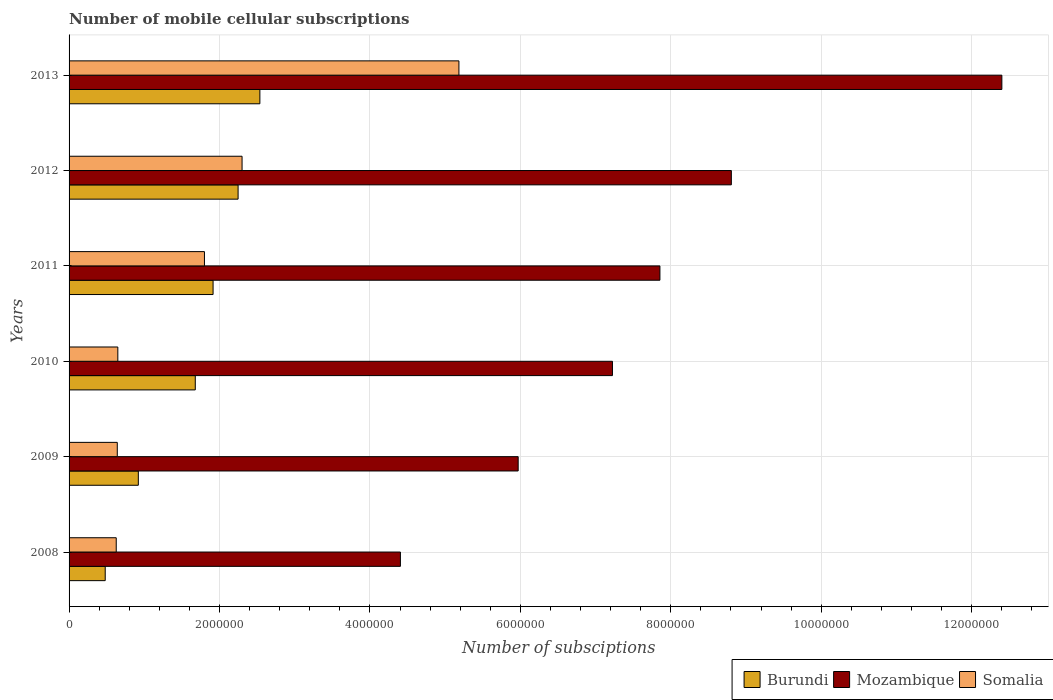How many different coloured bars are there?
Offer a very short reply. 3. Are the number of bars per tick equal to the number of legend labels?
Your answer should be compact. Yes. How many bars are there on the 1st tick from the bottom?
Offer a very short reply. 3. In how many cases, is the number of bars for a given year not equal to the number of legend labels?
Give a very brief answer. 0. What is the number of mobile cellular subscriptions in Mozambique in 2012?
Your response must be concise. 8.80e+06. Across all years, what is the maximum number of mobile cellular subscriptions in Mozambique?
Keep it short and to the point. 1.24e+07. Across all years, what is the minimum number of mobile cellular subscriptions in Burundi?
Your answer should be very brief. 4.81e+05. In which year was the number of mobile cellular subscriptions in Mozambique maximum?
Make the answer very short. 2013. In which year was the number of mobile cellular subscriptions in Somalia minimum?
Provide a succinct answer. 2008. What is the total number of mobile cellular subscriptions in Mozambique in the graph?
Ensure brevity in your answer.  4.67e+07. What is the difference between the number of mobile cellular subscriptions in Burundi in 2010 and that in 2011?
Ensure brevity in your answer.  -2.37e+05. What is the difference between the number of mobile cellular subscriptions in Somalia in 2009 and the number of mobile cellular subscriptions in Burundi in 2008?
Your response must be concise. 1.60e+05. What is the average number of mobile cellular subscriptions in Mozambique per year?
Provide a short and direct response. 7.78e+06. In the year 2010, what is the difference between the number of mobile cellular subscriptions in Burundi and number of mobile cellular subscriptions in Mozambique?
Your answer should be compact. -5.55e+06. What is the ratio of the number of mobile cellular subscriptions in Mozambique in 2010 to that in 2013?
Provide a short and direct response. 0.58. Is the number of mobile cellular subscriptions in Burundi in 2009 less than that in 2012?
Offer a terse response. Yes. Is the difference between the number of mobile cellular subscriptions in Burundi in 2008 and 2010 greater than the difference between the number of mobile cellular subscriptions in Mozambique in 2008 and 2010?
Your response must be concise. Yes. What is the difference between the highest and the second highest number of mobile cellular subscriptions in Somalia?
Offer a very short reply. 2.88e+06. What is the difference between the highest and the lowest number of mobile cellular subscriptions in Somalia?
Provide a short and direct response. 4.56e+06. In how many years, is the number of mobile cellular subscriptions in Mozambique greater than the average number of mobile cellular subscriptions in Mozambique taken over all years?
Your answer should be very brief. 3. Is the sum of the number of mobile cellular subscriptions in Somalia in 2011 and 2012 greater than the maximum number of mobile cellular subscriptions in Mozambique across all years?
Your answer should be very brief. No. What does the 3rd bar from the top in 2011 represents?
Keep it short and to the point. Burundi. What does the 3rd bar from the bottom in 2009 represents?
Provide a succinct answer. Somalia. Is it the case that in every year, the sum of the number of mobile cellular subscriptions in Somalia and number of mobile cellular subscriptions in Mozambique is greater than the number of mobile cellular subscriptions in Burundi?
Ensure brevity in your answer.  Yes. How many bars are there?
Ensure brevity in your answer.  18. How many years are there in the graph?
Your answer should be compact. 6. What is the difference between two consecutive major ticks on the X-axis?
Your answer should be compact. 2.00e+06. Where does the legend appear in the graph?
Offer a very short reply. Bottom right. How many legend labels are there?
Your response must be concise. 3. How are the legend labels stacked?
Make the answer very short. Horizontal. What is the title of the graph?
Your response must be concise. Number of mobile cellular subscriptions. Does "Kyrgyz Republic" appear as one of the legend labels in the graph?
Your answer should be very brief. No. What is the label or title of the X-axis?
Provide a succinct answer. Number of subsciptions. What is the label or title of the Y-axis?
Provide a short and direct response. Years. What is the Number of subsciptions of Burundi in 2008?
Offer a very short reply. 4.81e+05. What is the Number of subsciptions of Mozambique in 2008?
Your answer should be very brief. 4.41e+06. What is the Number of subsciptions in Somalia in 2008?
Your answer should be very brief. 6.27e+05. What is the Number of subsciptions in Burundi in 2009?
Provide a short and direct response. 9.21e+05. What is the Number of subsciptions of Mozambique in 2009?
Offer a very short reply. 5.97e+06. What is the Number of subsciptions in Somalia in 2009?
Make the answer very short. 6.41e+05. What is the Number of subsciptions in Burundi in 2010?
Offer a very short reply. 1.68e+06. What is the Number of subsciptions of Mozambique in 2010?
Give a very brief answer. 7.22e+06. What is the Number of subsciptions in Somalia in 2010?
Offer a very short reply. 6.48e+05. What is the Number of subsciptions of Burundi in 2011?
Offer a very short reply. 1.91e+06. What is the Number of subsciptions of Mozambique in 2011?
Provide a short and direct response. 7.86e+06. What is the Number of subsciptions in Somalia in 2011?
Offer a very short reply. 1.80e+06. What is the Number of subsciptions of Burundi in 2012?
Make the answer very short. 2.25e+06. What is the Number of subsciptions in Mozambique in 2012?
Provide a short and direct response. 8.80e+06. What is the Number of subsciptions in Somalia in 2012?
Ensure brevity in your answer.  2.30e+06. What is the Number of subsciptions of Burundi in 2013?
Keep it short and to the point. 2.54e+06. What is the Number of subsciptions of Mozambique in 2013?
Your answer should be very brief. 1.24e+07. What is the Number of subsciptions of Somalia in 2013?
Your response must be concise. 5.18e+06. Across all years, what is the maximum Number of subsciptions of Burundi?
Offer a very short reply. 2.54e+06. Across all years, what is the maximum Number of subsciptions in Mozambique?
Offer a very short reply. 1.24e+07. Across all years, what is the maximum Number of subsciptions of Somalia?
Keep it short and to the point. 5.18e+06. Across all years, what is the minimum Number of subsciptions of Burundi?
Make the answer very short. 4.81e+05. Across all years, what is the minimum Number of subsciptions of Mozambique?
Your answer should be very brief. 4.41e+06. Across all years, what is the minimum Number of subsciptions in Somalia?
Provide a short and direct response. 6.27e+05. What is the total Number of subsciptions of Burundi in the graph?
Keep it short and to the point. 9.78e+06. What is the total Number of subsciptions of Mozambique in the graph?
Your answer should be compact. 4.67e+07. What is the total Number of subsciptions in Somalia in the graph?
Offer a terse response. 1.12e+07. What is the difference between the Number of subsciptions in Burundi in 2008 and that in 2009?
Give a very brief answer. -4.40e+05. What is the difference between the Number of subsciptions in Mozambique in 2008 and that in 2009?
Provide a succinct answer. -1.57e+06. What is the difference between the Number of subsciptions of Somalia in 2008 and that in 2009?
Keep it short and to the point. -1.40e+04. What is the difference between the Number of subsciptions in Burundi in 2008 and that in 2010?
Offer a terse response. -1.20e+06. What is the difference between the Number of subsciptions of Mozambique in 2008 and that in 2010?
Your response must be concise. -2.82e+06. What is the difference between the Number of subsciptions in Somalia in 2008 and that in 2010?
Offer a very short reply. -2.12e+04. What is the difference between the Number of subsciptions of Burundi in 2008 and that in 2011?
Give a very brief answer. -1.43e+06. What is the difference between the Number of subsciptions in Mozambique in 2008 and that in 2011?
Your response must be concise. -3.45e+06. What is the difference between the Number of subsciptions in Somalia in 2008 and that in 2011?
Keep it short and to the point. -1.17e+06. What is the difference between the Number of subsciptions of Burundi in 2008 and that in 2012?
Your answer should be compact. -1.77e+06. What is the difference between the Number of subsciptions of Mozambique in 2008 and that in 2012?
Your answer should be compact. -4.40e+06. What is the difference between the Number of subsciptions in Somalia in 2008 and that in 2012?
Make the answer very short. -1.67e+06. What is the difference between the Number of subsciptions of Burundi in 2008 and that in 2013?
Your answer should be very brief. -2.06e+06. What is the difference between the Number of subsciptions of Mozambique in 2008 and that in 2013?
Make the answer very short. -8.00e+06. What is the difference between the Number of subsciptions of Somalia in 2008 and that in 2013?
Offer a terse response. -4.56e+06. What is the difference between the Number of subsciptions of Burundi in 2009 and that in 2010?
Give a very brief answer. -7.57e+05. What is the difference between the Number of subsciptions in Mozambique in 2009 and that in 2010?
Provide a short and direct response. -1.25e+06. What is the difference between the Number of subsciptions of Somalia in 2009 and that in 2010?
Provide a short and direct response. -7200. What is the difference between the Number of subsciptions in Burundi in 2009 and that in 2011?
Provide a short and direct response. -9.94e+05. What is the difference between the Number of subsciptions of Mozambique in 2009 and that in 2011?
Give a very brief answer. -1.88e+06. What is the difference between the Number of subsciptions in Somalia in 2009 and that in 2011?
Give a very brief answer. -1.16e+06. What is the difference between the Number of subsciptions of Burundi in 2009 and that in 2012?
Ensure brevity in your answer.  -1.33e+06. What is the difference between the Number of subsciptions of Mozambique in 2009 and that in 2012?
Keep it short and to the point. -2.83e+06. What is the difference between the Number of subsciptions in Somalia in 2009 and that in 2012?
Make the answer very short. -1.66e+06. What is the difference between the Number of subsciptions of Burundi in 2009 and that in 2013?
Provide a succinct answer. -1.62e+06. What is the difference between the Number of subsciptions in Mozambique in 2009 and that in 2013?
Your answer should be compact. -6.43e+06. What is the difference between the Number of subsciptions in Somalia in 2009 and that in 2013?
Your response must be concise. -4.54e+06. What is the difference between the Number of subsciptions in Burundi in 2010 and that in 2011?
Your answer should be compact. -2.37e+05. What is the difference between the Number of subsciptions in Mozambique in 2010 and that in 2011?
Provide a succinct answer. -6.31e+05. What is the difference between the Number of subsciptions of Somalia in 2010 and that in 2011?
Offer a very short reply. -1.15e+06. What is the difference between the Number of subsciptions of Burundi in 2010 and that in 2012?
Your answer should be very brief. -5.69e+05. What is the difference between the Number of subsciptions in Mozambique in 2010 and that in 2012?
Your response must be concise. -1.58e+06. What is the difference between the Number of subsciptions in Somalia in 2010 and that in 2012?
Offer a very short reply. -1.65e+06. What is the difference between the Number of subsciptions in Burundi in 2010 and that in 2013?
Provide a succinct answer. -8.59e+05. What is the difference between the Number of subsciptions of Mozambique in 2010 and that in 2013?
Provide a short and direct response. -5.18e+06. What is the difference between the Number of subsciptions of Somalia in 2010 and that in 2013?
Offer a very short reply. -4.53e+06. What is the difference between the Number of subsciptions in Burundi in 2011 and that in 2012?
Your answer should be very brief. -3.33e+05. What is the difference between the Number of subsciptions of Mozambique in 2011 and that in 2012?
Provide a short and direct response. -9.50e+05. What is the difference between the Number of subsciptions of Somalia in 2011 and that in 2012?
Give a very brief answer. -5.00e+05. What is the difference between the Number of subsciptions in Burundi in 2011 and that in 2013?
Make the answer very short. -6.22e+05. What is the difference between the Number of subsciptions in Mozambique in 2011 and that in 2013?
Ensure brevity in your answer.  -4.55e+06. What is the difference between the Number of subsciptions of Somalia in 2011 and that in 2013?
Your answer should be very brief. -3.38e+06. What is the difference between the Number of subsciptions of Burundi in 2012 and that in 2013?
Your response must be concise. -2.90e+05. What is the difference between the Number of subsciptions of Mozambique in 2012 and that in 2013?
Give a very brief answer. -3.60e+06. What is the difference between the Number of subsciptions in Somalia in 2012 and that in 2013?
Your answer should be very brief. -2.88e+06. What is the difference between the Number of subsciptions in Burundi in 2008 and the Number of subsciptions in Mozambique in 2009?
Provide a short and direct response. -5.49e+06. What is the difference between the Number of subsciptions in Burundi in 2008 and the Number of subsciptions in Somalia in 2009?
Make the answer very short. -1.60e+05. What is the difference between the Number of subsciptions of Mozambique in 2008 and the Number of subsciptions of Somalia in 2009?
Make the answer very short. 3.76e+06. What is the difference between the Number of subsciptions in Burundi in 2008 and the Number of subsciptions in Mozambique in 2010?
Provide a short and direct response. -6.74e+06. What is the difference between the Number of subsciptions in Burundi in 2008 and the Number of subsciptions in Somalia in 2010?
Make the answer very short. -1.68e+05. What is the difference between the Number of subsciptions of Mozambique in 2008 and the Number of subsciptions of Somalia in 2010?
Your response must be concise. 3.76e+06. What is the difference between the Number of subsciptions in Burundi in 2008 and the Number of subsciptions in Mozambique in 2011?
Offer a very short reply. -7.37e+06. What is the difference between the Number of subsciptions of Burundi in 2008 and the Number of subsciptions of Somalia in 2011?
Make the answer very short. -1.32e+06. What is the difference between the Number of subsciptions of Mozambique in 2008 and the Number of subsciptions of Somalia in 2011?
Your response must be concise. 2.61e+06. What is the difference between the Number of subsciptions of Burundi in 2008 and the Number of subsciptions of Mozambique in 2012?
Make the answer very short. -8.32e+06. What is the difference between the Number of subsciptions of Burundi in 2008 and the Number of subsciptions of Somalia in 2012?
Make the answer very short. -1.82e+06. What is the difference between the Number of subsciptions in Mozambique in 2008 and the Number of subsciptions in Somalia in 2012?
Your answer should be compact. 2.11e+06. What is the difference between the Number of subsciptions in Burundi in 2008 and the Number of subsciptions in Mozambique in 2013?
Keep it short and to the point. -1.19e+07. What is the difference between the Number of subsciptions in Burundi in 2008 and the Number of subsciptions in Somalia in 2013?
Keep it short and to the point. -4.70e+06. What is the difference between the Number of subsciptions of Mozambique in 2008 and the Number of subsciptions of Somalia in 2013?
Offer a very short reply. -7.78e+05. What is the difference between the Number of subsciptions of Burundi in 2009 and the Number of subsciptions of Mozambique in 2010?
Your answer should be very brief. -6.30e+06. What is the difference between the Number of subsciptions in Burundi in 2009 and the Number of subsciptions in Somalia in 2010?
Offer a terse response. 2.73e+05. What is the difference between the Number of subsciptions of Mozambique in 2009 and the Number of subsciptions of Somalia in 2010?
Your answer should be compact. 5.32e+06. What is the difference between the Number of subsciptions in Burundi in 2009 and the Number of subsciptions in Mozambique in 2011?
Your answer should be compact. -6.93e+06. What is the difference between the Number of subsciptions in Burundi in 2009 and the Number of subsciptions in Somalia in 2011?
Ensure brevity in your answer.  -8.79e+05. What is the difference between the Number of subsciptions in Mozambique in 2009 and the Number of subsciptions in Somalia in 2011?
Offer a very short reply. 4.17e+06. What is the difference between the Number of subsciptions of Burundi in 2009 and the Number of subsciptions of Mozambique in 2012?
Provide a succinct answer. -7.88e+06. What is the difference between the Number of subsciptions of Burundi in 2009 and the Number of subsciptions of Somalia in 2012?
Provide a succinct answer. -1.38e+06. What is the difference between the Number of subsciptions in Mozambique in 2009 and the Number of subsciptions in Somalia in 2012?
Offer a terse response. 3.67e+06. What is the difference between the Number of subsciptions of Burundi in 2009 and the Number of subsciptions of Mozambique in 2013?
Keep it short and to the point. -1.15e+07. What is the difference between the Number of subsciptions in Burundi in 2009 and the Number of subsciptions in Somalia in 2013?
Make the answer very short. -4.26e+06. What is the difference between the Number of subsciptions in Mozambique in 2009 and the Number of subsciptions in Somalia in 2013?
Provide a succinct answer. 7.88e+05. What is the difference between the Number of subsciptions of Burundi in 2010 and the Number of subsciptions of Mozambique in 2011?
Your answer should be compact. -6.18e+06. What is the difference between the Number of subsciptions of Burundi in 2010 and the Number of subsciptions of Somalia in 2011?
Your response must be concise. -1.22e+05. What is the difference between the Number of subsciptions in Mozambique in 2010 and the Number of subsciptions in Somalia in 2011?
Provide a short and direct response. 5.42e+06. What is the difference between the Number of subsciptions of Burundi in 2010 and the Number of subsciptions of Mozambique in 2012?
Keep it short and to the point. -7.13e+06. What is the difference between the Number of subsciptions of Burundi in 2010 and the Number of subsciptions of Somalia in 2012?
Keep it short and to the point. -6.22e+05. What is the difference between the Number of subsciptions of Mozambique in 2010 and the Number of subsciptions of Somalia in 2012?
Your answer should be very brief. 4.92e+06. What is the difference between the Number of subsciptions in Burundi in 2010 and the Number of subsciptions in Mozambique in 2013?
Make the answer very short. -1.07e+07. What is the difference between the Number of subsciptions of Burundi in 2010 and the Number of subsciptions of Somalia in 2013?
Your response must be concise. -3.50e+06. What is the difference between the Number of subsciptions of Mozambique in 2010 and the Number of subsciptions of Somalia in 2013?
Offer a terse response. 2.04e+06. What is the difference between the Number of subsciptions in Burundi in 2011 and the Number of subsciptions in Mozambique in 2012?
Give a very brief answer. -6.89e+06. What is the difference between the Number of subsciptions of Burundi in 2011 and the Number of subsciptions of Somalia in 2012?
Your response must be concise. -3.85e+05. What is the difference between the Number of subsciptions in Mozambique in 2011 and the Number of subsciptions in Somalia in 2012?
Offer a terse response. 5.56e+06. What is the difference between the Number of subsciptions of Burundi in 2011 and the Number of subsciptions of Mozambique in 2013?
Your response must be concise. -1.05e+07. What is the difference between the Number of subsciptions in Burundi in 2011 and the Number of subsciptions in Somalia in 2013?
Your response must be concise. -3.27e+06. What is the difference between the Number of subsciptions in Mozambique in 2011 and the Number of subsciptions in Somalia in 2013?
Ensure brevity in your answer.  2.67e+06. What is the difference between the Number of subsciptions of Burundi in 2012 and the Number of subsciptions of Mozambique in 2013?
Your answer should be very brief. -1.02e+07. What is the difference between the Number of subsciptions in Burundi in 2012 and the Number of subsciptions in Somalia in 2013?
Your answer should be compact. -2.94e+06. What is the difference between the Number of subsciptions of Mozambique in 2012 and the Number of subsciptions of Somalia in 2013?
Offer a terse response. 3.62e+06. What is the average Number of subsciptions in Burundi per year?
Make the answer very short. 1.63e+06. What is the average Number of subsciptions in Mozambique per year?
Ensure brevity in your answer.  7.78e+06. What is the average Number of subsciptions in Somalia per year?
Provide a succinct answer. 1.87e+06. In the year 2008, what is the difference between the Number of subsciptions of Burundi and Number of subsciptions of Mozambique?
Give a very brief answer. -3.92e+06. In the year 2008, what is the difference between the Number of subsciptions in Burundi and Number of subsciptions in Somalia?
Your answer should be compact. -1.46e+05. In the year 2008, what is the difference between the Number of subsciptions in Mozambique and Number of subsciptions in Somalia?
Keep it short and to the point. 3.78e+06. In the year 2009, what is the difference between the Number of subsciptions in Burundi and Number of subsciptions in Mozambique?
Provide a succinct answer. -5.05e+06. In the year 2009, what is the difference between the Number of subsciptions of Burundi and Number of subsciptions of Somalia?
Your response must be concise. 2.80e+05. In the year 2009, what is the difference between the Number of subsciptions of Mozambique and Number of subsciptions of Somalia?
Make the answer very short. 5.33e+06. In the year 2010, what is the difference between the Number of subsciptions of Burundi and Number of subsciptions of Mozambique?
Offer a very short reply. -5.55e+06. In the year 2010, what is the difference between the Number of subsciptions of Burundi and Number of subsciptions of Somalia?
Give a very brief answer. 1.03e+06. In the year 2010, what is the difference between the Number of subsciptions of Mozambique and Number of subsciptions of Somalia?
Your answer should be very brief. 6.58e+06. In the year 2011, what is the difference between the Number of subsciptions of Burundi and Number of subsciptions of Mozambique?
Provide a short and direct response. -5.94e+06. In the year 2011, what is the difference between the Number of subsciptions in Burundi and Number of subsciptions in Somalia?
Offer a very short reply. 1.15e+05. In the year 2011, what is the difference between the Number of subsciptions of Mozambique and Number of subsciptions of Somalia?
Make the answer very short. 6.06e+06. In the year 2012, what is the difference between the Number of subsciptions of Burundi and Number of subsciptions of Mozambique?
Provide a succinct answer. -6.56e+06. In the year 2012, what is the difference between the Number of subsciptions in Burundi and Number of subsciptions in Somalia?
Keep it short and to the point. -5.29e+04. In the year 2012, what is the difference between the Number of subsciptions of Mozambique and Number of subsciptions of Somalia?
Provide a succinct answer. 6.50e+06. In the year 2013, what is the difference between the Number of subsciptions in Burundi and Number of subsciptions in Mozambique?
Your response must be concise. -9.86e+06. In the year 2013, what is the difference between the Number of subsciptions of Burundi and Number of subsciptions of Somalia?
Give a very brief answer. -2.65e+06. In the year 2013, what is the difference between the Number of subsciptions in Mozambique and Number of subsciptions in Somalia?
Your answer should be compact. 7.22e+06. What is the ratio of the Number of subsciptions in Burundi in 2008 to that in 2009?
Your answer should be compact. 0.52. What is the ratio of the Number of subsciptions in Mozambique in 2008 to that in 2009?
Your answer should be very brief. 0.74. What is the ratio of the Number of subsciptions of Somalia in 2008 to that in 2009?
Offer a very short reply. 0.98. What is the ratio of the Number of subsciptions in Burundi in 2008 to that in 2010?
Keep it short and to the point. 0.29. What is the ratio of the Number of subsciptions in Mozambique in 2008 to that in 2010?
Ensure brevity in your answer.  0.61. What is the ratio of the Number of subsciptions in Somalia in 2008 to that in 2010?
Provide a short and direct response. 0.97. What is the ratio of the Number of subsciptions of Burundi in 2008 to that in 2011?
Ensure brevity in your answer.  0.25. What is the ratio of the Number of subsciptions of Mozambique in 2008 to that in 2011?
Keep it short and to the point. 0.56. What is the ratio of the Number of subsciptions of Somalia in 2008 to that in 2011?
Give a very brief answer. 0.35. What is the ratio of the Number of subsciptions of Burundi in 2008 to that in 2012?
Offer a terse response. 0.21. What is the ratio of the Number of subsciptions in Mozambique in 2008 to that in 2012?
Ensure brevity in your answer.  0.5. What is the ratio of the Number of subsciptions of Somalia in 2008 to that in 2012?
Your response must be concise. 0.27. What is the ratio of the Number of subsciptions of Burundi in 2008 to that in 2013?
Your answer should be very brief. 0.19. What is the ratio of the Number of subsciptions of Mozambique in 2008 to that in 2013?
Ensure brevity in your answer.  0.36. What is the ratio of the Number of subsciptions in Somalia in 2008 to that in 2013?
Keep it short and to the point. 0.12. What is the ratio of the Number of subsciptions in Burundi in 2009 to that in 2010?
Provide a succinct answer. 0.55. What is the ratio of the Number of subsciptions of Mozambique in 2009 to that in 2010?
Make the answer very short. 0.83. What is the ratio of the Number of subsciptions in Somalia in 2009 to that in 2010?
Provide a short and direct response. 0.99. What is the ratio of the Number of subsciptions of Burundi in 2009 to that in 2011?
Ensure brevity in your answer.  0.48. What is the ratio of the Number of subsciptions in Mozambique in 2009 to that in 2011?
Your response must be concise. 0.76. What is the ratio of the Number of subsciptions in Somalia in 2009 to that in 2011?
Your response must be concise. 0.36. What is the ratio of the Number of subsciptions of Burundi in 2009 to that in 2012?
Keep it short and to the point. 0.41. What is the ratio of the Number of subsciptions of Mozambique in 2009 to that in 2012?
Your response must be concise. 0.68. What is the ratio of the Number of subsciptions in Somalia in 2009 to that in 2012?
Ensure brevity in your answer.  0.28. What is the ratio of the Number of subsciptions of Burundi in 2009 to that in 2013?
Provide a short and direct response. 0.36. What is the ratio of the Number of subsciptions in Mozambique in 2009 to that in 2013?
Ensure brevity in your answer.  0.48. What is the ratio of the Number of subsciptions of Somalia in 2009 to that in 2013?
Provide a short and direct response. 0.12. What is the ratio of the Number of subsciptions in Burundi in 2010 to that in 2011?
Your response must be concise. 0.88. What is the ratio of the Number of subsciptions in Mozambique in 2010 to that in 2011?
Give a very brief answer. 0.92. What is the ratio of the Number of subsciptions of Somalia in 2010 to that in 2011?
Offer a terse response. 0.36. What is the ratio of the Number of subsciptions in Burundi in 2010 to that in 2012?
Offer a very short reply. 0.75. What is the ratio of the Number of subsciptions in Mozambique in 2010 to that in 2012?
Your response must be concise. 0.82. What is the ratio of the Number of subsciptions of Somalia in 2010 to that in 2012?
Ensure brevity in your answer.  0.28. What is the ratio of the Number of subsciptions in Burundi in 2010 to that in 2013?
Provide a succinct answer. 0.66. What is the ratio of the Number of subsciptions in Mozambique in 2010 to that in 2013?
Offer a terse response. 0.58. What is the ratio of the Number of subsciptions of Somalia in 2010 to that in 2013?
Your answer should be compact. 0.13. What is the ratio of the Number of subsciptions in Burundi in 2011 to that in 2012?
Make the answer very short. 0.85. What is the ratio of the Number of subsciptions in Mozambique in 2011 to that in 2012?
Keep it short and to the point. 0.89. What is the ratio of the Number of subsciptions of Somalia in 2011 to that in 2012?
Provide a succinct answer. 0.78. What is the ratio of the Number of subsciptions in Burundi in 2011 to that in 2013?
Provide a succinct answer. 0.75. What is the ratio of the Number of subsciptions of Mozambique in 2011 to that in 2013?
Offer a terse response. 0.63. What is the ratio of the Number of subsciptions of Somalia in 2011 to that in 2013?
Give a very brief answer. 0.35. What is the ratio of the Number of subsciptions in Burundi in 2012 to that in 2013?
Ensure brevity in your answer.  0.89. What is the ratio of the Number of subsciptions of Mozambique in 2012 to that in 2013?
Keep it short and to the point. 0.71. What is the ratio of the Number of subsciptions in Somalia in 2012 to that in 2013?
Provide a short and direct response. 0.44. What is the difference between the highest and the second highest Number of subsciptions in Burundi?
Provide a short and direct response. 2.90e+05. What is the difference between the highest and the second highest Number of subsciptions in Mozambique?
Your response must be concise. 3.60e+06. What is the difference between the highest and the second highest Number of subsciptions of Somalia?
Your response must be concise. 2.88e+06. What is the difference between the highest and the lowest Number of subsciptions of Burundi?
Give a very brief answer. 2.06e+06. What is the difference between the highest and the lowest Number of subsciptions in Mozambique?
Offer a terse response. 8.00e+06. What is the difference between the highest and the lowest Number of subsciptions in Somalia?
Give a very brief answer. 4.56e+06. 